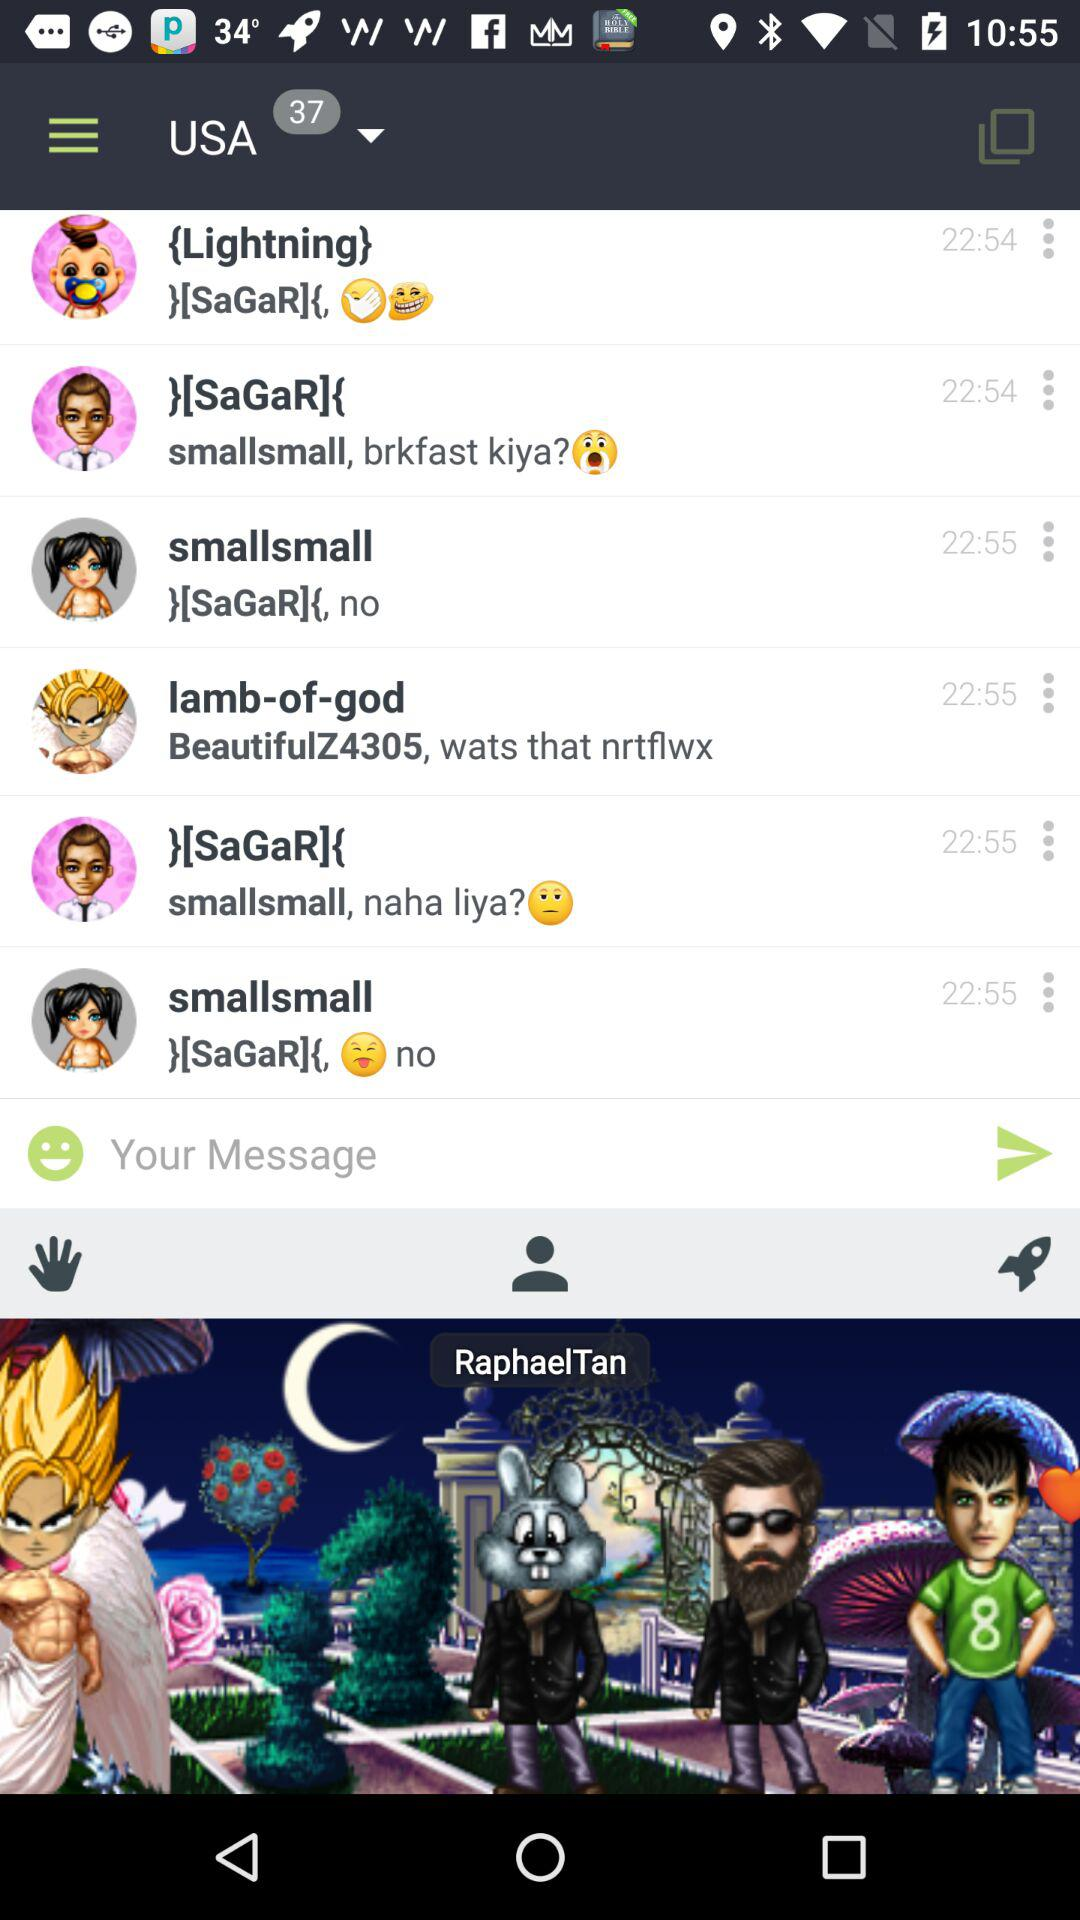What is the selected country? The selected country is "USA". 